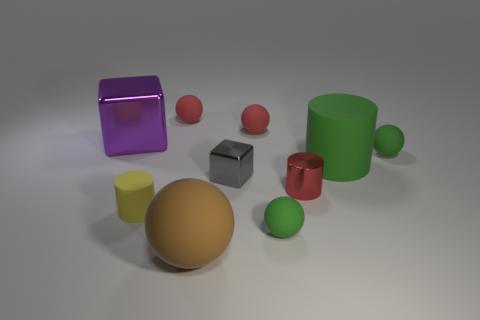Subtract all large balls. How many balls are left? 4 Subtract all red spheres. How many spheres are left? 3 Subtract 1 blocks. How many blocks are left? 1 Subtract all cylinders. How many objects are left? 7 Subtract all cyan cubes. How many green balls are left? 2 Subtract 0 purple cylinders. How many objects are left? 10 Subtract all yellow cubes. Subtract all brown spheres. How many cubes are left? 2 Subtract all red metallic cylinders. Subtract all green balls. How many objects are left? 7 Add 4 small green spheres. How many small green spheres are left? 6 Add 5 big gray metal cylinders. How many big gray metal cylinders exist? 5 